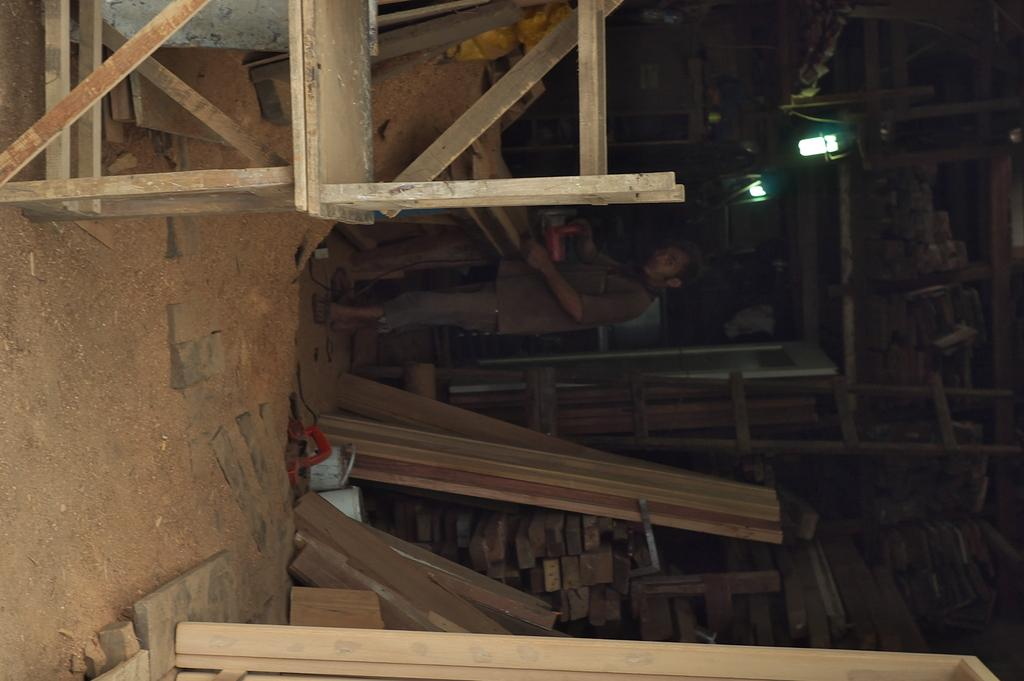What type of furniture can be seen in the image? There are tables in the image. What is the man in the image doing? The man is cutting wood with a machine. What can be seen illuminating the area in the image? There are lights visible in the image. Where is the wood stored in the image? There is a pile of wood in a shelf. What is present on the ground in the image? Wooden planks are present on the ground. What type of wool is being spun by the pigs in the image? There are no pigs or wool present in the image; it features tables, a man cutting wood, lights, a pile of wood in a shelf, and wooden planks on the ground. 